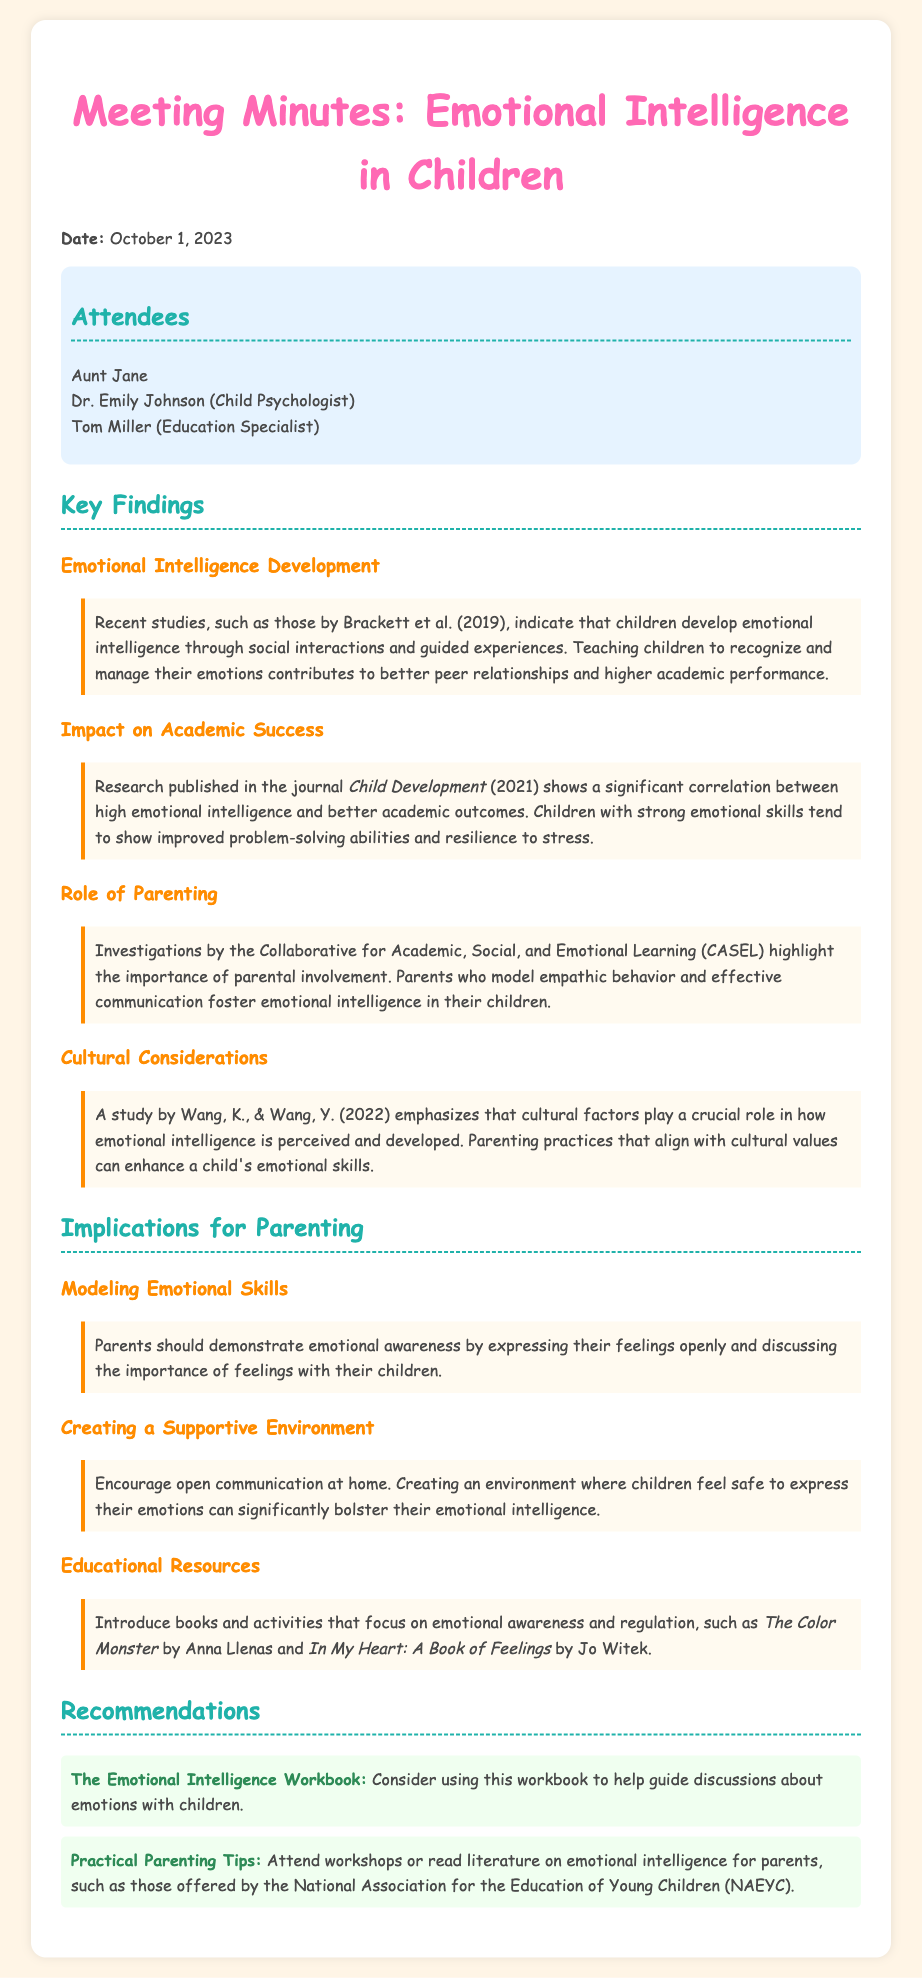What is the date of the meeting? The date of the meeting is specified in the document.
Answer: October 1, 2023 Who presented the findings? The attendees list mentions a child psychologist who likely presents.
Answer: Dr. Emily Johnson Which study is mentioned regarding emotional intelligence development? The document cites specific studies about emotional intelligence.
Answer: Brackett et al. (2019) What is one of the key implications for parenting? The implications section outlines various ways parents can help children.
Answer: Modeling emotional skills Name one of the recommended books for parents. The recommendations section includes specific educational resources.
Answer: The Color Monster What was emphasized to influence emotional skills according to cultural factors? The document discusses the impact of cultural factors on emotional intelligence development.
Answer: Parenting practices How should parents create an environment for emotional expression? The document describes what parents can do to support children emotionally.
Answer: Supportive environment Which workshop organization is mentioned for parents? The recommendations provide sources for further learning on emotional intelligence.
Answer: National Association for the Education of Young Children (NAEYC) 